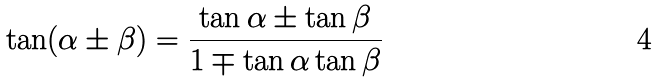<formula> <loc_0><loc_0><loc_500><loc_500>\tan ( \alpha \pm \beta ) = { \frac { \tan \alpha \pm \tan \beta } { 1 \mp \tan \alpha \tan \beta } }</formula> 